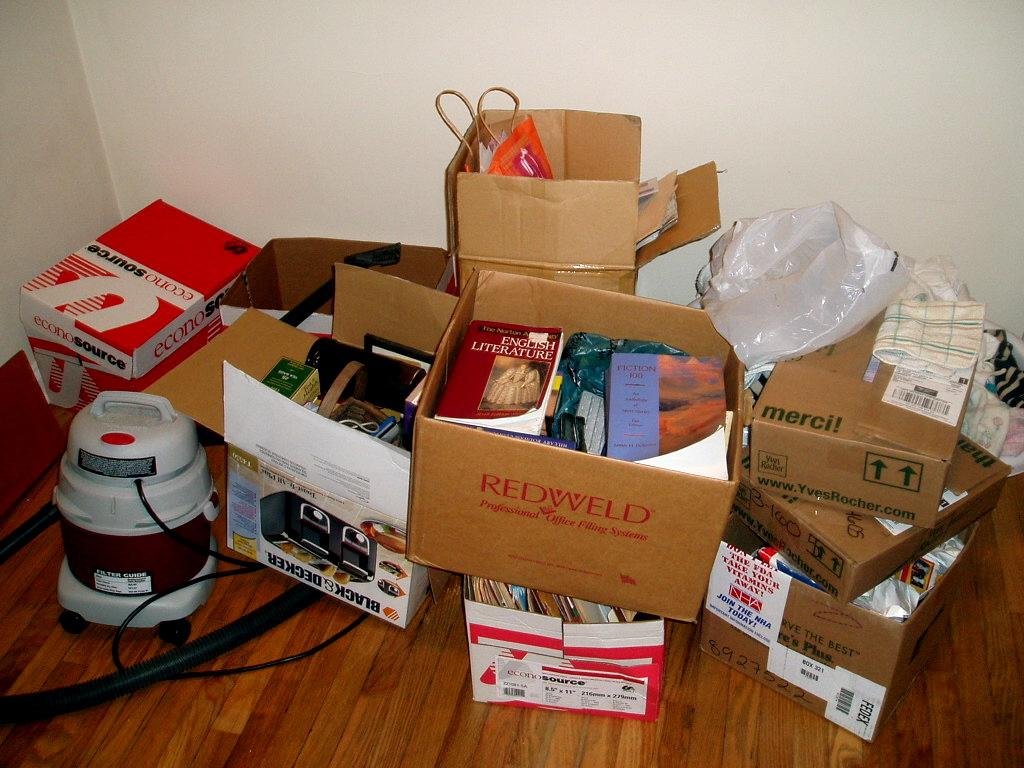<image>
Give a short and clear explanation of the subsequent image. A redweld box is filled with many books. 